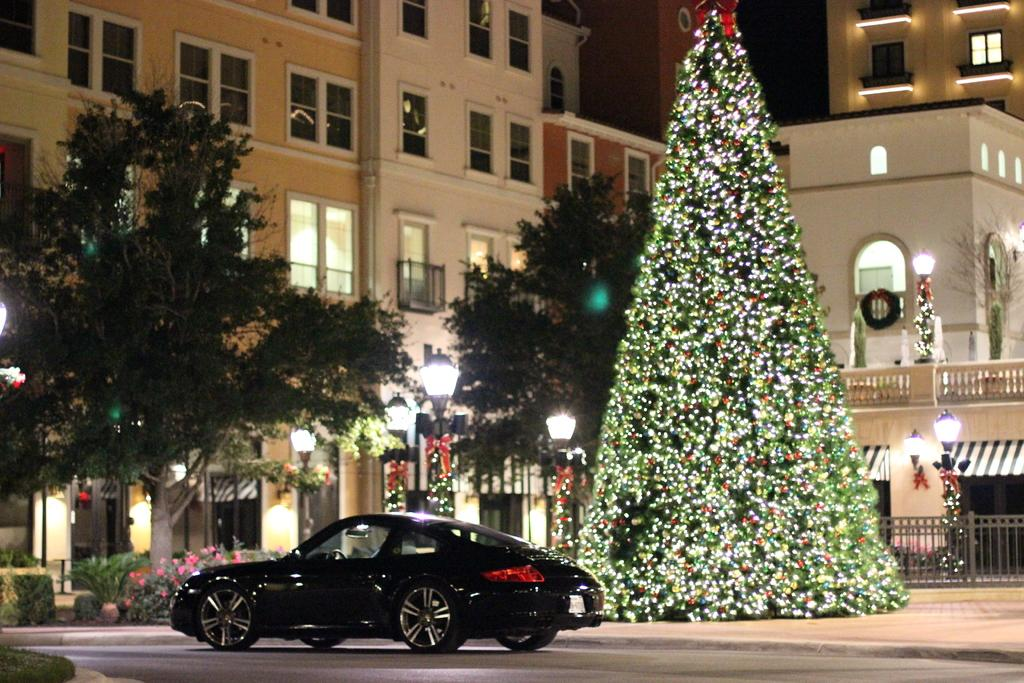What is the main subject of the image? There is a car on the road in the image. What type of vegetation can be seen in the image? There are plants and trees in the image. What can be seen in the image that might provide illumination? There are lights in the image. What type of barrier is present in the image? There are fences in the image. What season might be suggested by the presence of a Christmas tree in the image? The presence of a Christmas tree suggests that the image might be taken during the winter season. What other objects can be seen in the image besides the car and vegetation? There are various objects in the image. What type of structures can be seen in the background of the image? There are buildings with windows in the background of the image. What type of cake is being served at the sink in the image? There is no cake or sink present in the image. What type of bird can be seen perched on the robin in the image? There is no bird or robin present in the image. 